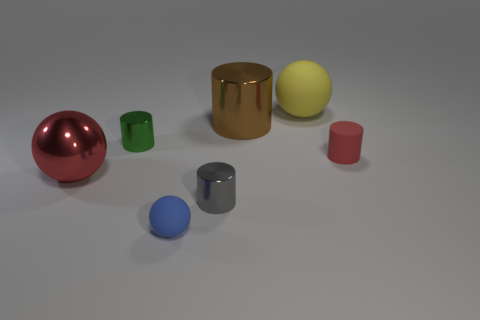Subtract all rubber cylinders. How many cylinders are left? 3 Subtract 1 balls. How many balls are left? 2 Subtract all green cylinders. How many cylinders are left? 3 Subtract all cylinders. How many objects are left? 3 Subtract all small blue cylinders. Subtract all brown metallic objects. How many objects are left? 6 Add 1 yellow rubber objects. How many yellow rubber objects are left? 2 Add 1 small purple metal things. How many small purple metal things exist? 1 Add 2 red matte cylinders. How many objects exist? 9 Subtract 0 brown blocks. How many objects are left? 7 Subtract all blue spheres. Subtract all yellow cylinders. How many spheres are left? 2 